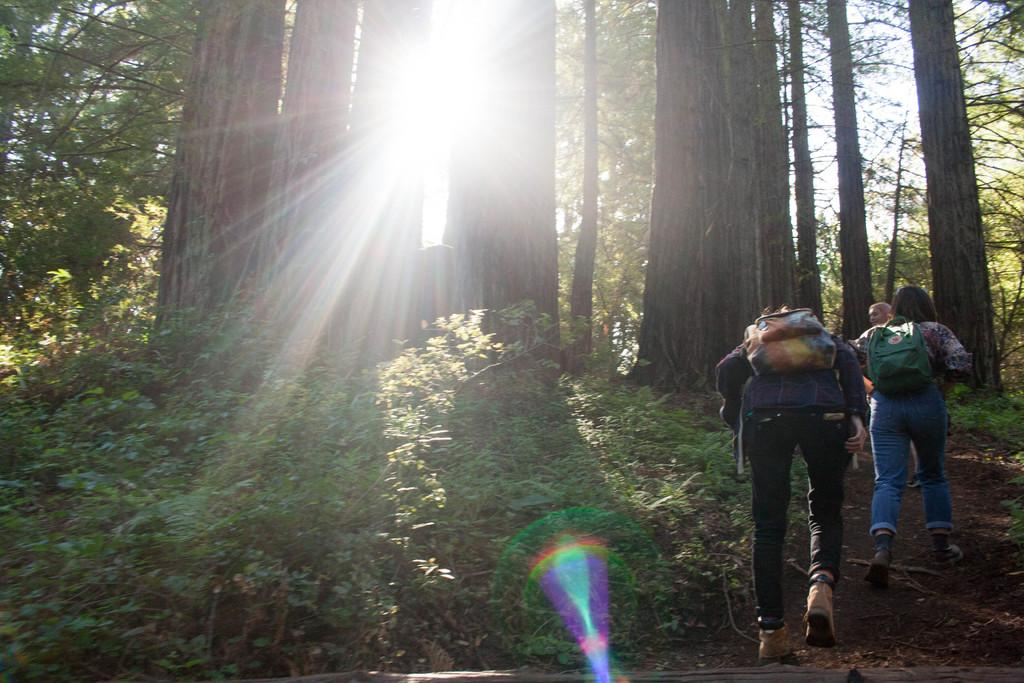What are the people in the image doing? The people in the image are climbing on the right side. What can be seen in the foreground of the image? There are plants in the foreground of the image. What type of vegetation is in the middle of the image? There are trees in the middle of the image. What is the condition of the sky in the background of the image? The sun is shining in the sky in the background of the image. How many pages are visible in the image? There are no pages present in the image. Is there an island visible in the image? There is no island visible in the image. 